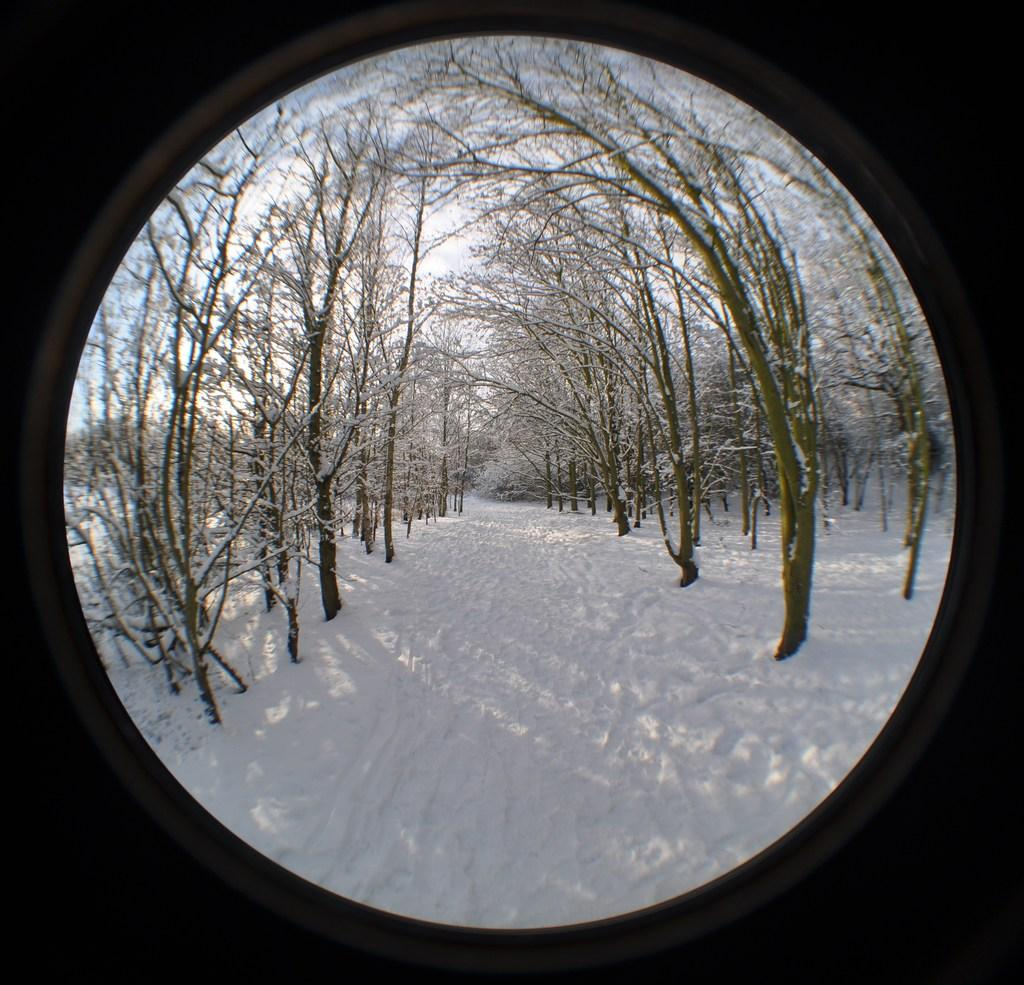What is the main feature of the image? There is a hole in the image. What can be seen through the hole? The hole reveals a snowy surface. What is present on the snowy surface? There are dried trees on the snowy surface. What can be seen in the background of the image? The sky is visible in the background of the image. What type of key is used to unlock the border in the image? There is no key or border present in the image; it features a hole revealing a snowy surface with dried trees. 